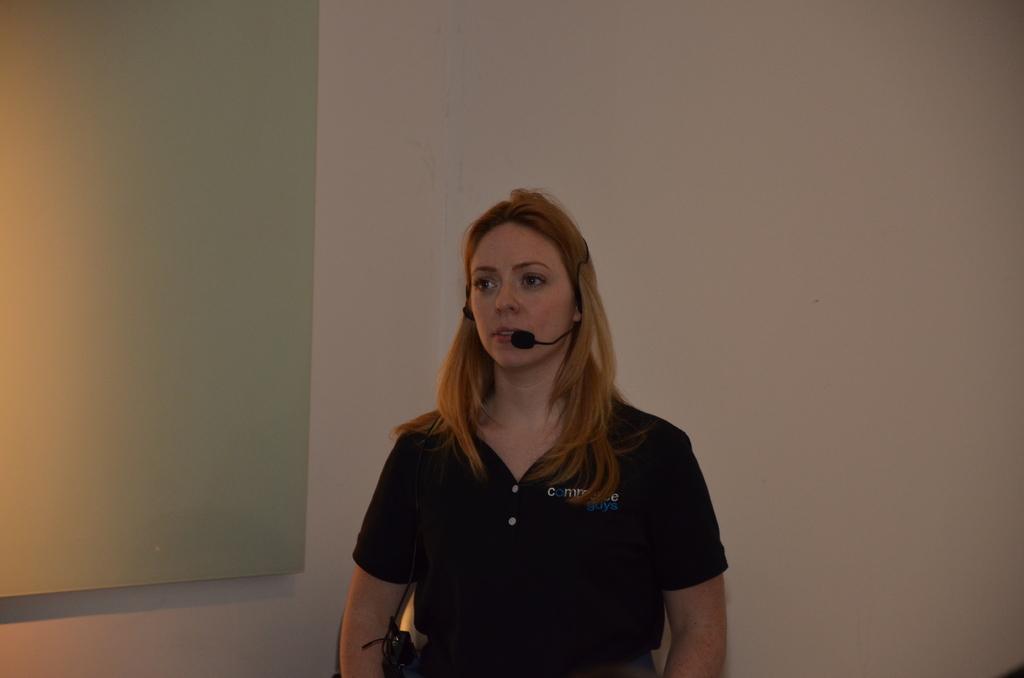In one or two sentences, can you explain what this image depicts? In the picture we can see a woman standing, she is with black T-shirt and a microphone which is connected in her mouth and behind her we can see a wall and on it we can see a white color board. 